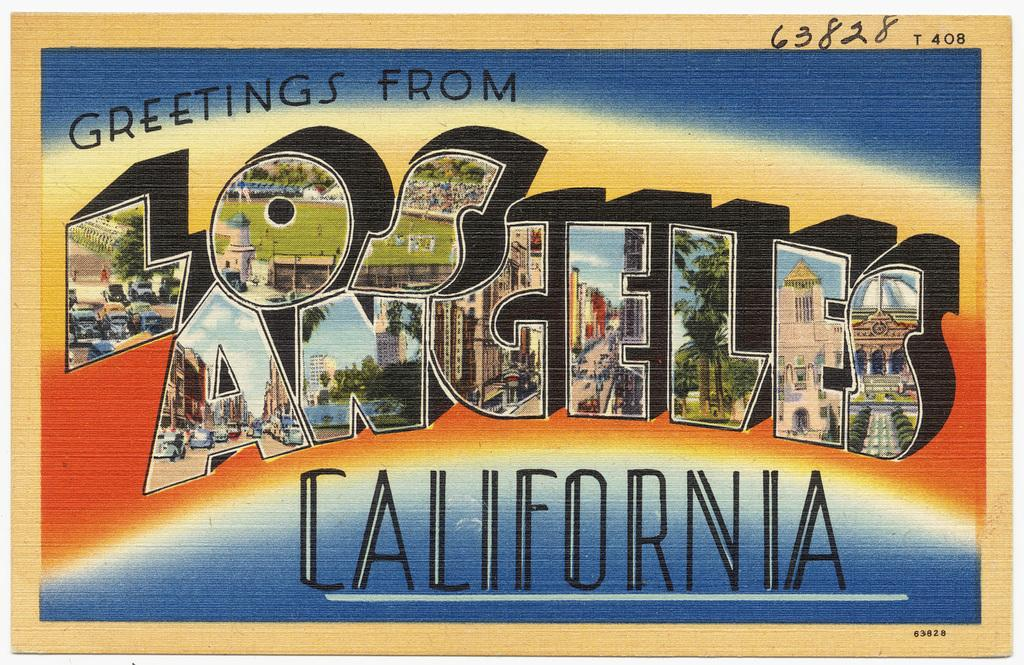Provide a one-sentence caption for the provided image. A post card from Los Angeles California containing pictures on each letter. 